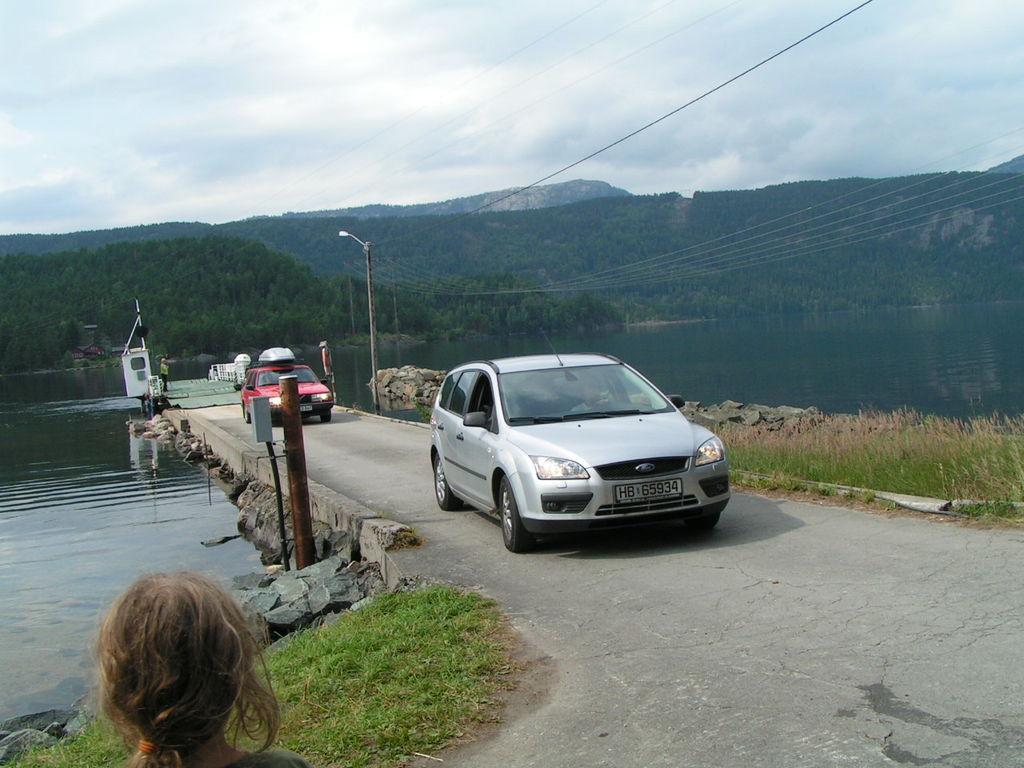Could you give a brief overview of what you see in this image? In this image we can see cars on the road. At the bottom there is a person and we can see grass. In the background there is water and we can see hills, poles and sky. There are wires. 